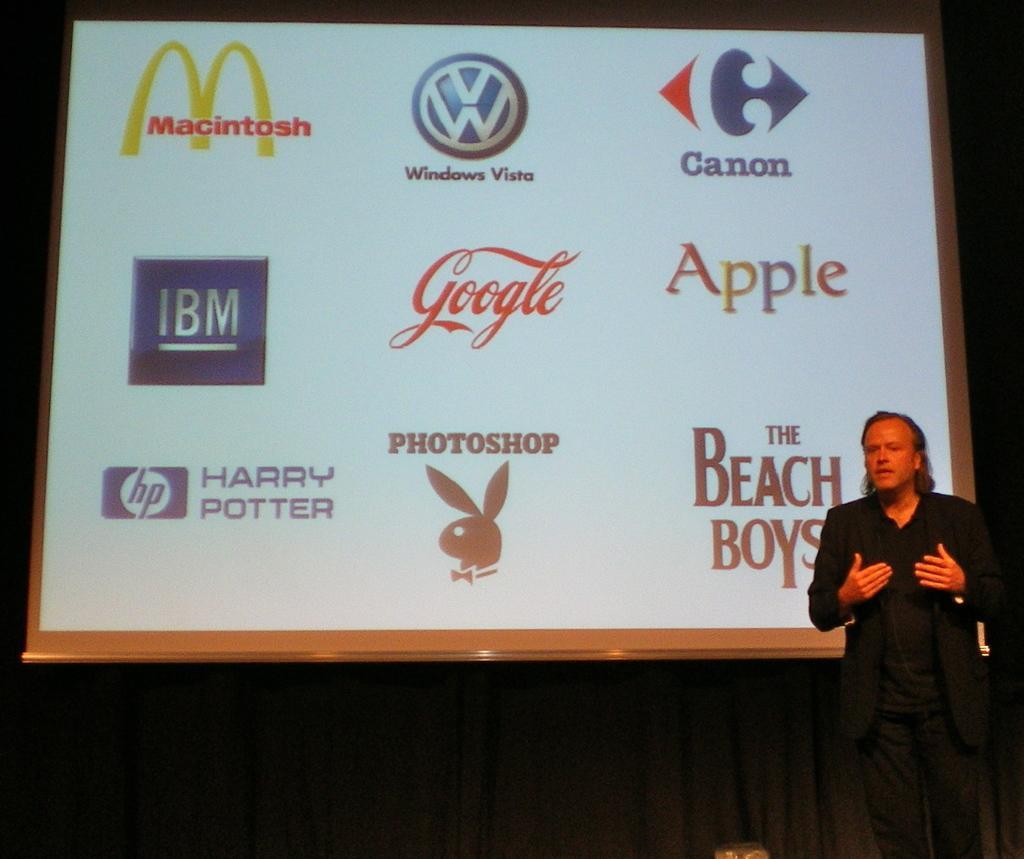Could you give a brief overview of what you see in this image? On the right side, there is a person in a black color dress, standing and speaking. In the background, there is a screen arranged. And the background is dark in color. 